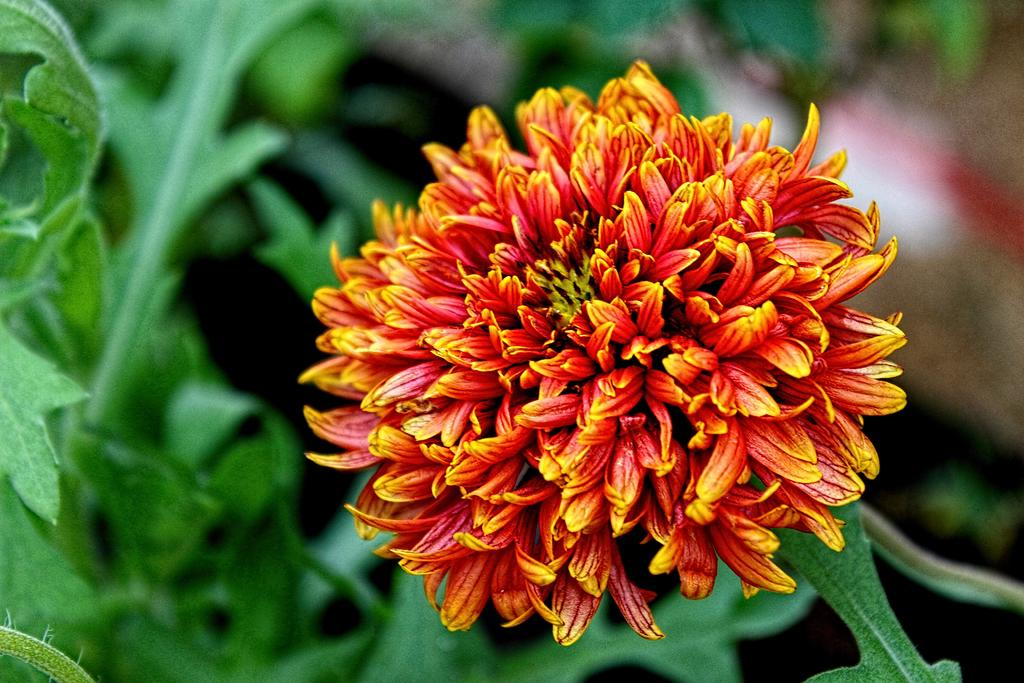What is the main subject in the middle of the image? There is a flower in the middle of the image. What can be seen in the background of the image? There are green leaves in the background of the image. How many eggs are visible in the image? There are no eggs present in the image. What type of sand can be seen in the image? There is no sand present in the image. 